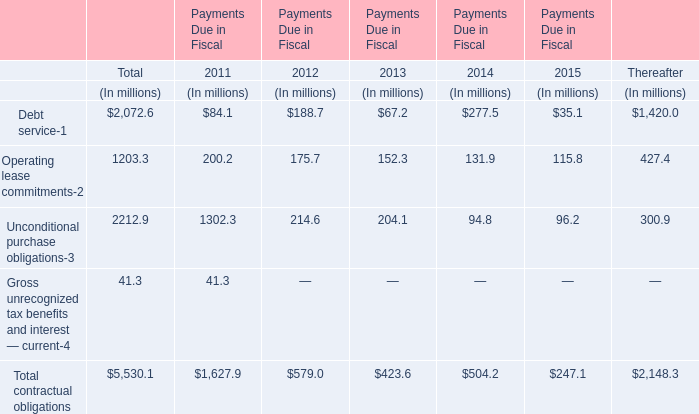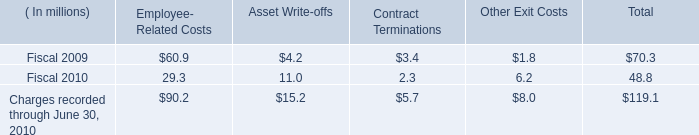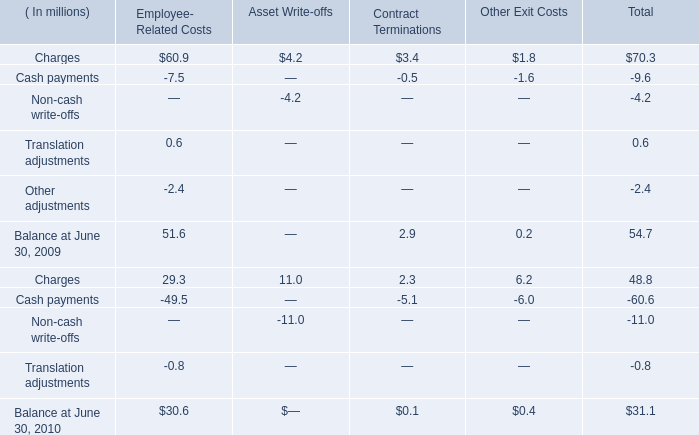If Contract Terminations develops with the same increasing rate in 2010, what will it reach in 2011? (in million) 
Computations: ((1 + ((2.3 - 3.4) / 3.4)) * 2.3)
Answer: 1.55588. 